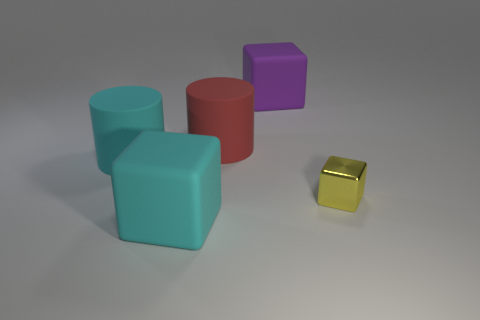What shape is the big rubber thing that is to the left of the large rubber cube that is in front of the metal thing?
Your response must be concise. Cylinder. Is there anything else that is the same size as the yellow block?
Ensure brevity in your answer.  No. What is the shape of the large matte object that is behind the large red thing that is in front of the rubber cube that is right of the big cyan rubber block?
Offer a terse response. Cube. What number of objects are either cyan cylinders that are to the left of the large purple rubber cube or big cubes that are in front of the large purple matte block?
Your answer should be compact. 2. There is a purple matte thing; does it have the same size as the cube that is left of the purple matte object?
Your response must be concise. Yes. Is the material of the big block that is behind the big cyan cube the same as the yellow object to the right of the large cyan block?
Keep it short and to the point. No. Are there the same number of large cylinders that are behind the red object and big rubber blocks to the left of the large purple matte thing?
Offer a very short reply. No. How many small cubes are the same color as the shiny object?
Provide a succinct answer. 0. How many rubber things are cylinders or tiny brown things?
Keep it short and to the point. 2. There is a object to the left of the large cyan matte cube; is it the same shape as the red object to the right of the big cyan matte cube?
Offer a very short reply. Yes. 